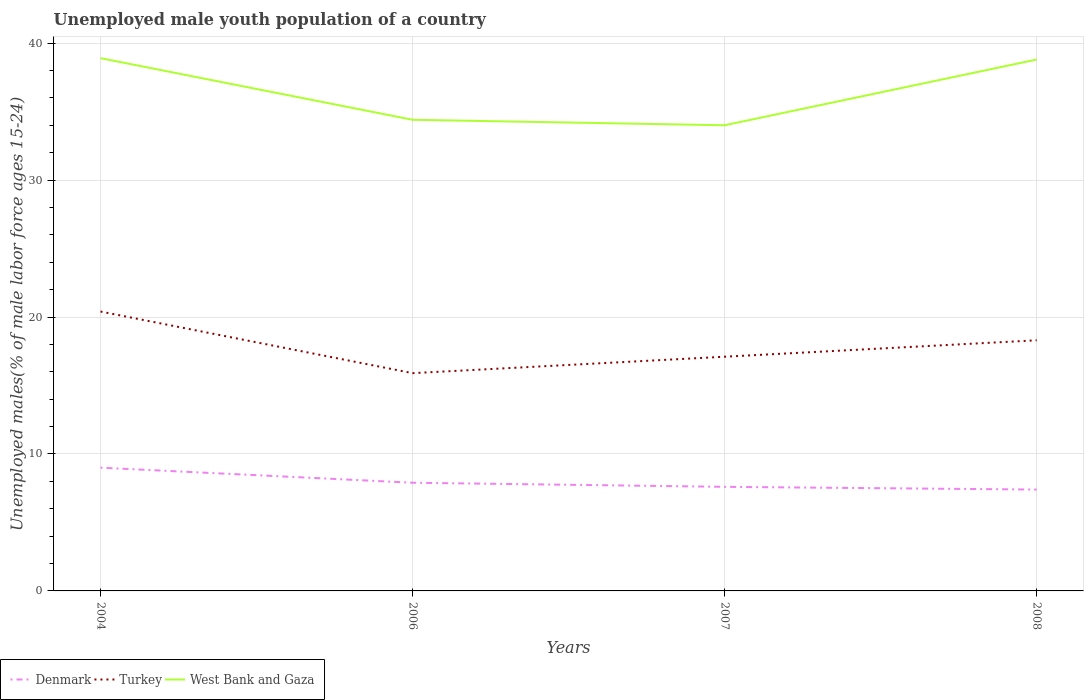How many different coloured lines are there?
Make the answer very short. 3. Across all years, what is the maximum percentage of unemployed male youth population in West Bank and Gaza?
Your answer should be very brief. 34. What is the total percentage of unemployed male youth population in Denmark in the graph?
Your response must be concise. 1.1. What is the difference between the highest and the second highest percentage of unemployed male youth population in Denmark?
Make the answer very short. 1.6. How many lines are there?
Keep it short and to the point. 3. What is the difference between two consecutive major ticks on the Y-axis?
Your answer should be very brief. 10. Are the values on the major ticks of Y-axis written in scientific E-notation?
Offer a very short reply. No. Does the graph contain any zero values?
Keep it short and to the point. No. Where does the legend appear in the graph?
Provide a short and direct response. Bottom left. How many legend labels are there?
Your answer should be very brief. 3. What is the title of the graph?
Your answer should be very brief. Unemployed male youth population of a country. Does "Belarus" appear as one of the legend labels in the graph?
Offer a very short reply. No. What is the label or title of the X-axis?
Make the answer very short. Years. What is the label or title of the Y-axis?
Your answer should be very brief. Unemployed males(% of male labor force ages 15-24). What is the Unemployed males(% of male labor force ages 15-24) in Turkey in 2004?
Make the answer very short. 20.4. What is the Unemployed males(% of male labor force ages 15-24) in West Bank and Gaza in 2004?
Offer a very short reply. 38.9. What is the Unemployed males(% of male labor force ages 15-24) in Denmark in 2006?
Provide a short and direct response. 7.9. What is the Unemployed males(% of male labor force ages 15-24) of Turkey in 2006?
Your answer should be very brief. 15.9. What is the Unemployed males(% of male labor force ages 15-24) in West Bank and Gaza in 2006?
Your answer should be very brief. 34.4. What is the Unemployed males(% of male labor force ages 15-24) in Denmark in 2007?
Provide a succinct answer. 7.6. What is the Unemployed males(% of male labor force ages 15-24) in Turkey in 2007?
Keep it short and to the point. 17.1. What is the Unemployed males(% of male labor force ages 15-24) in West Bank and Gaza in 2007?
Provide a succinct answer. 34. What is the Unemployed males(% of male labor force ages 15-24) of Denmark in 2008?
Offer a terse response. 7.4. What is the Unemployed males(% of male labor force ages 15-24) in Turkey in 2008?
Offer a very short reply. 18.3. What is the Unemployed males(% of male labor force ages 15-24) of West Bank and Gaza in 2008?
Offer a terse response. 38.8. Across all years, what is the maximum Unemployed males(% of male labor force ages 15-24) of Turkey?
Your response must be concise. 20.4. Across all years, what is the maximum Unemployed males(% of male labor force ages 15-24) of West Bank and Gaza?
Make the answer very short. 38.9. Across all years, what is the minimum Unemployed males(% of male labor force ages 15-24) in Denmark?
Give a very brief answer. 7.4. Across all years, what is the minimum Unemployed males(% of male labor force ages 15-24) in Turkey?
Offer a terse response. 15.9. What is the total Unemployed males(% of male labor force ages 15-24) in Denmark in the graph?
Ensure brevity in your answer.  31.9. What is the total Unemployed males(% of male labor force ages 15-24) in Turkey in the graph?
Your answer should be compact. 71.7. What is the total Unemployed males(% of male labor force ages 15-24) of West Bank and Gaza in the graph?
Make the answer very short. 146.1. What is the difference between the Unemployed males(% of male labor force ages 15-24) in Turkey in 2004 and that in 2006?
Provide a succinct answer. 4.5. What is the difference between the Unemployed males(% of male labor force ages 15-24) in Denmark in 2004 and that in 2007?
Offer a very short reply. 1.4. What is the difference between the Unemployed males(% of male labor force ages 15-24) in Turkey in 2004 and that in 2007?
Provide a succinct answer. 3.3. What is the difference between the Unemployed males(% of male labor force ages 15-24) in Denmark in 2004 and that in 2008?
Provide a short and direct response. 1.6. What is the difference between the Unemployed males(% of male labor force ages 15-24) of West Bank and Gaza in 2004 and that in 2008?
Your answer should be compact. 0.1. What is the difference between the Unemployed males(% of male labor force ages 15-24) of Denmark in 2006 and that in 2007?
Offer a terse response. 0.3. What is the difference between the Unemployed males(% of male labor force ages 15-24) of West Bank and Gaza in 2006 and that in 2007?
Ensure brevity in your answer.  0.4. What is the difference between the Unemployed males(% of male labor force ages 15-24) of Denmark in 2006 and that in 2008?
Give a very brief answer. 0.5. What is the difference between the Unemployed males(% of male labor force ages 15-24) in Turkey in 2006 and that in 2008?
Provide a succinct answer. -2.4. What is the difference between the Unemployed males(% of male labor force ages 15-24) of Denmark in 2004 and the Unemployed males(% of male labor force ages 15-24) of Turkey in 2006?
Provide a short and direct response. -6.9. What is the difference between the Unemployed males(% of male labor force ages 15-24) of Denmark in 2004 and the Unemployed males(% of male labor force ages 15-24) of West Bank and Gaza in 2006?
Make the answer very short. -25.4. What is the difference between the Unemployed males(% of male labor force ages 15-24) in Turkey in 2004 and the Unemployed males(% of male labor force ages 15-24) in West Bank and Gaza in 2006?
Your answer should be compact. -14. What is the difference between the Unemployed males(% of male labor force ages 15-24) of Denmark in 2004 and the Unemployed males(% of male labor force ages 15-24) of West Bank and Gaza in 2008?
Make the answer very short. -29.8. What is the difference between the Unemployed males(% of male labor force ages 15-24) in Turkey in 2004 and the Unemployed males(% of male labor force ages 15-24) in West Bank and Gaza in 2008?
Offer a very short reply. -18.4. What is the difference between the Unemployed males(% of male labor force ages 15-24) in Denmark in 2006 and the Unemployed males(% of male labor force ages 15-24) in West Bank and Gaza in 2007?
Keep it short and to the point. -26.1. What is the difference between the Unemployed males(% of male labor force ages 15-24) in Turkey in 2006 and the Unemployed males(% of male labor force ages 15-24) in West Bank and Gaza in 2007?
Provide a succinct answer. -18.1. What is the difference between the Unemployed males(% of male labor force ages 15-24) of Denmark in 2006 and the Unemployed males(% of male labor force ages 15-24) of Turkey in 2008?
Keep it short and to the point. -10.4. What is the difference between the Unemployed males(% of male labor force ages 15-24) in Denmark in 2006 and the Unemployed males(% of male labor force ages 15-24) in West Bank and Gaza in 2008?
Your answer should be compact. -30.9. What is the difference between the Unemployed males(% of male labor force ages 15-24) of Turkey in 2006 and the Unemployed males(% of male labor force ages 15-24) of West Bank and Gaza in 2008?
Ensure brevity in your answer.  -22.9. What is the difference between the Unemployed males(% of male labor force ages 15-24) of Denmark in 2007 and the Unemployed males(% of male labor force ages 15-24) of Turkey in 2008?
Offer a very short reply. -10.7. What is the difference between the Unemployed males(% of male labor force ages 15-24) in Denmark in 2007 and the Unemployed males(% of male labor force ages 15-24) in West Bank and Gaza in 2008?
Provide a succinct answer. -31.2. What is the difference between the Unemployed males(% of male labor force ages 15-24) of Turkey in 2007 and the Unemployed males(% of male labor force ages 15-24) of West Bank and Gaza in 2008?
Your answer should be very brief. -21.7. What is the average Unemployed males(% of male labor force ages 15-24) of Denmark per year?
Keep it short and to the point. 7.97. What is the average Unemployed males(% of male labor force ages 15-24) in Turkey per year?
Keep it short and to the point. 17.93. What is the average Unemployed males(% of male labor force ages 15-24) of West Bank and Gaza per year?
Your response must be concise. 36.52. In the year 2004, what is the difference between the Unemployed males(% of male labor force ages 15-24) of Denmark and Unemployed males(% of male labor force ages 15-24) of Turkey?
Your response must be concise. -11.4. In the year 2004, what is the difference between the Unemployed males(% of male labor force ages 15-24) of Denmark and Unemployed males(% of male labor force ages 15-24) of West Bank and Gaza?
Make the answer very short. -29.9. In the year 2004, what is the difference between the Unemployed males(% of male labor force ages 15-24) in Turkey and Unemployed males(% of male labor force ages 15-24) in West Bank and Gaza?
Keep it short and to the point. -18.5. In the year 2006, what is the difference between the Unemployed males(% of male labor force ages 15-24) of Denmark and Unemployed males(% of male labor force ages 15-24) of West Bank and Gaza?
Provide a short and direct response. -26.5. In the year 2006, what is the difference between the Unemployed males(% of male labor force ages 15-24) in Turkey and Unemployed males(% of male labor force ages 15-24) in West Bank and Gaza?
Provide a short and direct response. -18.5. In the year 2007, what is the difference between the Unemployed males(% of male labor force ages 15-24) of Denmark and Unemployed males(% of male labor force ages 15-24) of West Bank and Gaza?
Ensure brevity in your answer.  -26.4. In the year 2007, what is the difference between the Unemployed males(% of male labor force ages 15-24) of Turkey and Unemployed males(% of male labor force ages 15-24) of West Bank and Gaza?
Provide a succinct answer. -16.9. In the year 2008, what is the difference between the Unemployed males(% of male labor force ages 15-24) in Denmark and Unemployed males(% of male labor force ages 15-24) in Turkey?
Your answer should be compact. -10.9. In the year 2008, what is the difference between the Unemployed males(% of male labor force ages 15-24) of Denmark and Unemployed males(% of male labor force ages 15-24) of West Bank and Gaza?
Make the answer very short. -31.4. In the year 2008, what is the difference between the Unemployed males(% of male labor force ages 15-24) of Turkey and Unemployed males(% of male labor force ages 15-24) of West Bank and Gaza?
Ensure brevity in your answer.  -20.5. What is the ratio of the Unemployed males(% of male labor force ages 15-24) of Denmark in 2004 to that in 2006?
Provide a succinct answer. 1.14. What is the ratio of the Unemployed males(% of male labor force ages 15-24) of Turkey in 2004 to that in 2006?
Your response must be concise. 1.28. What is the ratio of the Unemployed males(% of male labor force ages 15-24) in West Bank and Gaza in 2004 to that in 2006?
Keep it short and to the point. 1.13. What is the ratio of the Unemployed males(% of male labor force ages 15-24) of Denmark in 2004 to that in 2007?
Make the answer very short. 1.18. What is the ratio of the Unemployed males(% of male labor force ages 15-24) of Turkey in 2004 to that in 2007?
Your response must be concise. 1.19. What is the ratio of the Unemployed males(% of male labor force ages 15-24) of West Bank and Gaza in 2004 to that in 2007?
Your answer should be very brief. 1.14. What is the ratio of the Unemployed males(% of male labor force ages 15-24) of Denmark in 2004 to that in 2008?
Your response must be concise. 1.22. What is the ratio of the Unemployed males(% of male labor force ages 15-24) in Turkey in 2004 to that in 2008?
Provide a short and direct response. 1.11. What is the ratio of the Unemployed males(% of male labor force ages 15-24) in Denmark in 2006 to that in 2007?
Ensure brevity in your answer.  1.04. What is the ratio of the Unemployed males(% of male labor force ages 15-24) of Turkey in 2006 to that in 2007?
Ensure brevity in your answer.  0.93. What is the ratio of the Unemployed males(% of male labor force ages 15-24) of West Bank and Gaza in 2006 to that in 2007?
Your response must be concise. 1.01. What is the ratio of the Unemployed males(% of male labor force ages 15-24) of Denmark in 2006 to that in 2008?
Your response must be concise. 1.07. What is the ratio of the Unemployed males(% of male labor force ages 15-24) of Turkey in 2006 to that in 2008?
Your answer should be very brief. 0.87. What is the ratio of the Unemployed males(% of male labor force ages 15-24) of West Bank and Gaza in 2006 to that in 2008?
Give a very brief answer. 0.89. What is the ratio of the Unemployed males(% of male labor force ages 15-24) of Denmark in 2007 to that in 2008?
Your response must be concise. 1.03. What is the ratio of the Unemployed males(% of male labor force ages 15-24) in Turkey in 2007 to that in 2008?
Your response must be concise. 0.93. What is the ratio of the Unemployed males(% of male labor force ages 15-24) of West Bank and Gaza in 2007 to that in 2008?
Offer a terse response. 0.88. What is the difference between the highest and the second highest Unemployed males(% of male labor force ages 15-24) in Denmark?
Offer a very short reply. 1.1. What is the difference between the highest and the second highest Unemployed males(% of male labor force ages 15-24) of West Bank and Gaza?
Give a very brief answer. 0.1. What is the difference between the highest and the lowest Unemployed males(% of male labor force ages 15-24) in Turkey?
Your answer should be compact. 4.5. What is the difference between the highest and the lowest Unemployed males(% of male labor force ages 15-24) of West Bank and Gaza?
Your answer should be very brief. 4.9. 